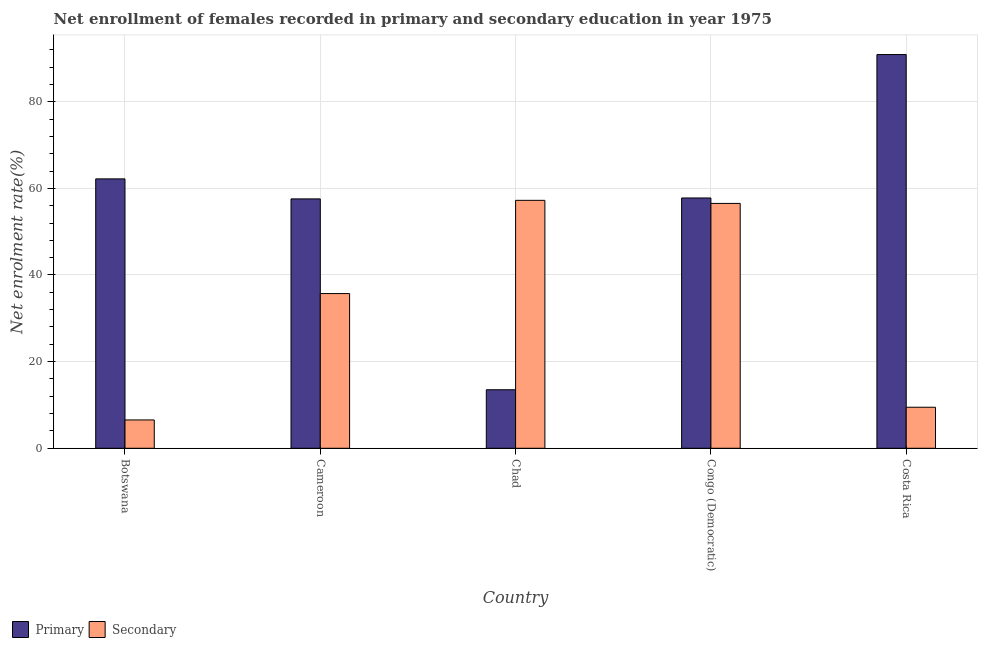How many groups of bars are there?
Your response must be concise. 5. Are the number of bars per tick equal to the number of legend labels?
Provide a succinct answer. Yes. Are the number of bars on each tick of the X-axis equal?
Offer a terse response. Yes. How many bars are there on the 5th tick from the right?
Keep it short and to the point. 2. What is the label of the 2nd group of bars from the left?
Offer a terse response. Cameroon. What is the enrollment rate in secondary education in Botswana?
Keep it short and to the point. 6.54. Across all countries, what is the maximum enrollment rate in secondary education?
Provide a succinct answer. 57.23. Across all countries, what is the minimum enrollment rate in secondary education?
Provide a short and direct response. 6.54. In which country was the enrollment rate in secondary education maximum?
Keep it short and to the point. Chad. In which country was the enrollment rate in secondary education minimum?
Your response must be concise. Botswana. What is the total enrollment rate in secondary education in the graph?
Your response must be concise. 165.48. What is the difference between the enrollment rate in primary education in Botswana and that in Chad?
Make the answer very short. 48.67. What is the difference between the enrollment rate in secondary education in Chad and the enrollment rate in primary education in Costa Rica?
Ensure brevity in your answer.  -33.65. What is the average enrollment rate in primary education per country?
Offer a terse response. 56.39. What is the difference between the enrollment rate in primary education and enrollment rate in secondary education in Costa Rica?
Your answer should be compact. 81.41. In how many countries, is the enrollment rate in primary education greater than 36 %?
Ensure brevity in your answer.  4. What is the ratio of the enrollment rate in secondary education in Chad to that in Costa Rica?
Make the answer very short. 6.04. Is the enrollment rate in primary education in Cameroon less than that in Costa Rica?
Make the answer very short. Yes. What is the difference between the highest and the second highest enrollment rate in primary education?
Your answer should be very brief. 28.7. What is the difference between the highest and the lowest enrollment rate in primary education?
Offer a very short reply. 77.37. Is the sum of the enrollment rate in secondary education in Chad and Costa Rica greater than the maximum enrollment rate in primary education across all countries?
Make the answer very short. No. What does the 1st bar from the left in Chad represents?
Ensure brevity in your answer.  Primary. What does the 2nd bar from the right in Botswana represents?
Ensure brevity in your answer.  Primary. How many bars are there?
Provide a succinct answer. 10. Are all the bars in the graph horizontal?
Keep it short and to the point. No. How many legend labels are there?
Keep it short and to the point. 2. What is the title of the graph?
Provide a succinct answer. Net enrollment of females recorded in primary and secondary education in year 1975. What is the label or title of the X-axis?
Provide a short and direct response. Country. What is the label or title of the Y-axis?
Provide a short and direct response. Net enrolment rate(%). What is the Net enrolment rate(%) of Primary in Botswana?
Keep it short and to the point. 62.19. What is the Net enrolment rate(%) in Secondary in Botswana?
Your response must be concise. 6.54. What is the Net enrolment rate(%) of Primary in Cameroon?
Offer a terse response. 57.57. What is the Net enrolment rate(%) in Secondary in Cameroon?
Ensure brevity in your answer.  35.71. What is the Net enrolment rate(%) of Primary in Chad?
Provide a succinct answer. 13.51. What is the Net enrolment rate(%) of Secondary in Chad?
Provide a succinct answer. 57.23. What is the Net enrolment rate(%) in Primary in Congo (Democratic)?
Offer a very short reply. 57.78. What is the Net enrolment rate(%) of Secondary in Congo (Democratic)?
Provide a short and direct response. 56.52. What is the Net enrolment rate(%) of Primary in Costa Rica?
Your response must be concise. 90.88. What is the Net enrolment rate(%) of Secondary in Costa Rica?
Ensure brevity in your answer.  9.47. Across all countries, what is the maximum Net enrolment rate(%) of Primary?
Your answer should be compact. 90.88. Across all countries, what is the maximum Net enrolment rate(%) of Secondary?
Offer a terse response. 57.23. Across all countries, what is the minimum Net enrolment rate(%) of Primary?
Provide a succinct answer. 13.51. Across all countries, what is the minimum Net enrolment rate(%) of Secondary?
Your answer should be compact. 6.54. What is the total Net enrolment rate(%) of Primary in the graph?
Offer a terse response. 281.93. What is the total Net enrolment rate(%) in Secondary in the graph?
Provide a succinct answer. 165.48. What is the difference between the Net enrolment rate(%) in Primary in Botswana and that in Cameroon?
Make the answer very short. 4.62. What is the difference between the Net enrolment rate(%) of Secondary in Botswana and that in Cameroon?
Your answer should be very brief. -29.17. What is the difference between the Net enrolment rate(%) of Primary in Botswana and that in Chad?
Give a very brief answer. 48.67. What is the difference between the Net enrolment rate(%) of Secondary in Botswana and that in Chad?
Ensure brevity in your answer.  -50.69. What is the difference between the Net enrolment rate(%) of Primary in Botswana and that in Congo (Democratic)?
Ensure brevity in your answer.  4.41. What is the difference between the Net enrolment rate(%) of Secondary in Botswana and that in Congo (Democratic)?
Provide a short and direct response. -49.98. What is the difference between the Net enrolment rate(%) in Primary in Botswana and that in Costa Rica?
Offer a very short reply. -28.7. What is the difference between the Net enrolment rate(%) in Secondary in Botswana and that in Costa Rica?
Offer a very short reply. -2.94. What is the difference between the Net enrolment rate(%) of Primary in Cameroon and that in Chad?
Make the answer very short. 44.05. What is the difference between the Net enrolment rate(%) in Secondary in Cameroon and that in Chad?
Your response must be concise. -21.52. What is the difference between the Net enrolment rate(%) of Primary in Cameroon and that in Congo (Democratic)?
Ensure brevity in your answer.  -0.21. What is the difference between the Net enrolment rate(%) in Secondary in Cameroon and that in Congo (Democratic)?
Provide a succinct answer. -20.81. What is the difference between the Net enrolment rate(%) of Primary in Cameroon and that in Costa Rica?
Make the answer very short. -33.32. What is the difference between the Net enrolment rate(%) of Secondary in Cameroon and that in Costa Rica?
Make the answer very short. 26.24. What is the difference between the Net enrolment rate(%) in Primary in Chad and that in Congo (Democratic)?
Offer a terse response. -44.26. What is the difference between the Net enrolment rate(%) of Secondary in Chad and that in Congo (Democratic)?
Keep it short and to the point. 0.71. What is the difference between the Net enrolment rate(%) in Primary in Chad and that in Costa Rica?
Provide a succinct answer. -77.37. What is the difference between the Net enrolment rate(%) in Secondary in Chad and that in Costa Rica?
Offer a terse response. 47.76. What is the difference between the Net enrolment rate(%) in Primary in Congo (Democratic) and that in Costa Rica?
Offer a very short reply. -33.1. What is the difference between the Net enrolment rate(%) in Secondary in Congo (Democratic) and that in Costa Rica?
Your answer should be compact. 47.05. What is the difference between the Net enrolment rate(%) of Primary in Botswana and the Net enrolment rate(%) of Secondary in Cameroon?
Your answer should be very brief. 26.47. What is the difference between the Net enrolment rate(%) in Primary in Botswana and the Net enrolment rate(%) in Secondary in Chad?
Your answer should be compact. 4.95. What is the difference between the Net enrolment rate(%) in Primary in Botswana and the Net enrolment rate(%) in Secondary in Congo (Democratic)?
Ensure brevity in your answer.  5.66. What is the difference between the Net enrolment rate(%) in Primary in Botswana and the Net enrolment rate(%) in Secondary in Costa Rica?
Your response must be concise. 52.71. What is the difference between the Net enrolment rate(%) in Primary in Cameroon and the Net enrolment rate(%) in Secondary in Chad?
Your answer should be compact. 0.33. What is the difference between the Net enrolment rate(%) in Primary in Cameroon and the Net enrolment rate(%) in Secondary in Congo (Democratic)?
Offer a terse response. 1.04. What is the difference between the Net enrolment rate(%) of Primary in Cameroon and the Net enrolment rate(%) of Secondary in Costa Rica?
Ensure brevity in your answer.  48.09. What is the difference between the Net enrolment rate(%) of Primary in Chad and the Net enrolment rate(%) of Secondary in Congo (Democratic)?
Your answer should be very brief. -43.01. What is the difference between the Net enrolment rate(%) of Primary in Chad and the Net enrolment rate(%) of Secondary in Costa Rica?
Make the answer very short. 4.04. What is the difference between the Net enrolment rate(%) in Primary in Congo (Democratic) and the Net enrolment rate(%) in Secondary in Costa Rica?
Ensure brevity in your answer.  48.3. What is the average Net enrolment rate(%) in Primary per country?
Your answer should be very brief. 56.39. What is the average Net enrolment rate(%) of Secondary per country?
Offer a very short reply. 33.1. What is the difference between the Net enrolment rate(%) in Primary and Net enrolment rate(%) in Secondary in Botswana?
Your answer should be very brief. 55.65. What is the difference between the Net enrolment rate(%) in Primary and Net enrolment rate(%) in Secondary in Cameroon?
Provide a short and direct response. 21.85. What is the difference between the Net enrolment rate(%) of Primary and Net enrolment rate(%) of Secondary in Chad?
Offer a terse response. -43.72. What is the difference between the Net enrolment rate(%) of Primary and Net enrolment rate(%) of Secondary in Congo (Democratic)?
Offer a terse response. 1.25. What is the difference between the Net enrolment rate(%) of Primary and Net enrolment rate(%) of Secondary in Costa Rica?
Provide a short and direct response. 81.41. What is the ratio of the Net enrolment rate(%) of Primary in Botswana to that in Cameroon?
Your response must be concise. 1.08. What is the ratio of the Net enrolment rate(%) in Secondary in Botswana to that in Cameroon?
Provide a short and direct response. 0.18. What is the ratio of the Net enrolment rate(%) of Primary in Botswana to that in Chad?
Your answer should be very brief. 4.6. What is the ratio of the Net enrolment rate(%) in Secondary in Botswana to that in Chad?
Offer a very short reply. 0.11. What is the ratio of the Net enrolment rate(%) of Primary in Botswana to that in Congo (Democratic)?
Your answer should be compact. 1.08. What is the ratio of the Net enrolment rate(%) of Secondary in Botswana to that in Congo (Democratic)?
Offer a very short reply. 0.12. What is the ratio of the Net enrolment rate(%) of Primary in Botswana to that in Costa Rica?
Ensure brevity in your answer.  0.68. What is the ratio of the Net enrolment rate(%) in Secondary in Botswana to that in Costa Rica?
Your answer should be compact. 0.69. What is the ratio of the Net enrolment rate(%) in Primary in Cameroon to that in Chad?
Keep it short and to the point. 4.26. What is the ratio of the Net enrolment rate(%) in Secondary in Cameroon to that in Chad?
Your answer should be very brief. 0.62. What is the ratio of the Net enrolment rate(%) in Primary in Cameroon to that in Congo (Democratic)?
Provide a short and direct response. 1. What is the ratio of the Net enrolment rate(%) of Secondary in Cameroon to that in Congo (Democratic)?
Provide a short and direct response. 0.63. What is the ratio of the Net enrolment rate(%) of Primary in Cameroon to that in Costa Rica?
Ensure brevity in your answer.  0.63. What is the ratio of the Net enrolment rate(%) of Secondary in Cameroon to that in Costa Rica?
Provide a short and direct response. 3.77. What is the ratio of the Net enrolment rate(%) of Primary in Chad to that in Congo (Democratic)?
Offer a terse response. 0.23. What is the ratio of the Net enrolment rate(%) of Secondary in Chad to that in Congo (Democratic)?
Provide a succinct answer. 1.01. What is the ratio of the Net enrolment rate(%) of Primary in Chad to that in Costa Rica?
Provide a succinct answer. 0.15. What is the ratio of the Net enrolment rate(%) of Secondary in Chad to that in Costa Rica?
Make the answer very short. 6.04. What is the ratio of the Net enrolment rate(%) in Primary in Congo (Democratic) to that in Costa Rica?
Make the answer very short. 0.64. What is the ratio of the Net enrolment rate(%) in Secondary in Congo (Democratic) to that in Costa Rica?
Your answer should be compact. 5.97. What is the difference between the highest and the second highest Net enrolment rate(%) in Primary?
Your answer should be very brief. 28.7. What is the difference between the highest and the second highest Net enrolment rate(%) of Secondary?
Provide a succinct answer. 0.71. What is the difference between the highest and the lowest Net enrolment rate(%) of Primary?
Keep it short and to the point. 77.37. What is the difference between the highest and the lowest Net enrolment rate(%) of Secondary?
Ensure brevity in your answer.  50.69. 